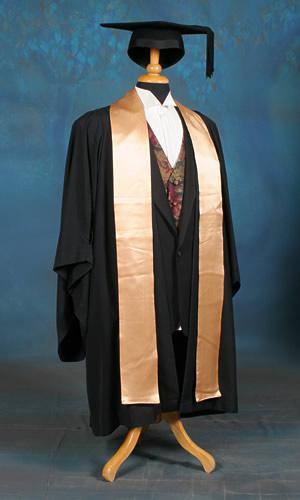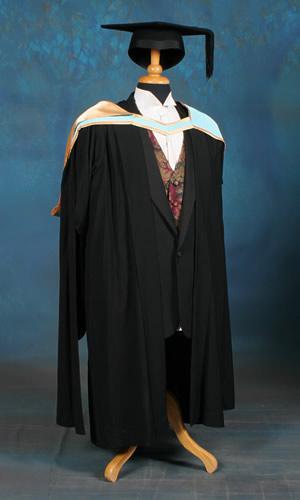The first image is the image on the left, the second image is the image on the right. For the images displayed, is the sentence "There is one an wearing a graduation gown" factually correct? Answer yes or no. No. The first image is the image on the left, the second image is the image on the right. Examine the images to the left and right. Is the description "One image contains at least one living young male model." accurate? Answer yes or no. No. 